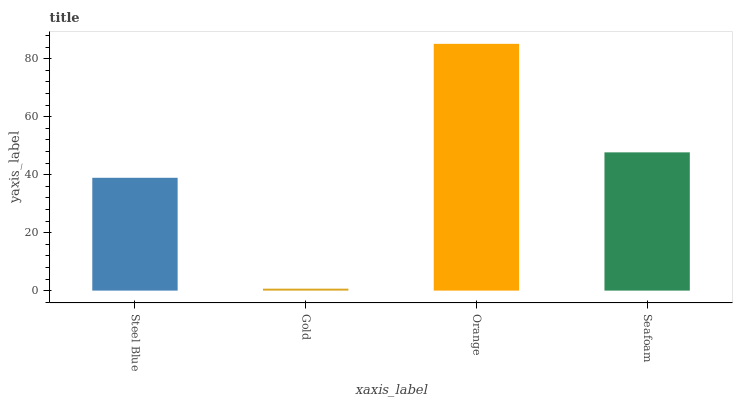Is Gold the minimum?
Answer yes or no. Yes. Is Orange the maximum?
Answer yes or no. Yes. Is Orange the minimum?
Answer yes or no. No. Is Gold the maximum?
Answer yes or no. No. Is Orange greater than Gold?
Answer yes or no. Yes. Is Gold less than Orange?
Answer yes or no. Yes. Is Gold greater than Orange?
Answer yes or no. No. Is Orange less than Gold?
Answer yes or no. No. Is Seafoam the high median?
Answer yes or no. Yes. Is Steel Blue the low median?
Answer yes or no. Yes. Is Orange the high median?
Answer yes or no. No. Is Orange the low median?
Answer yes or no. No. 